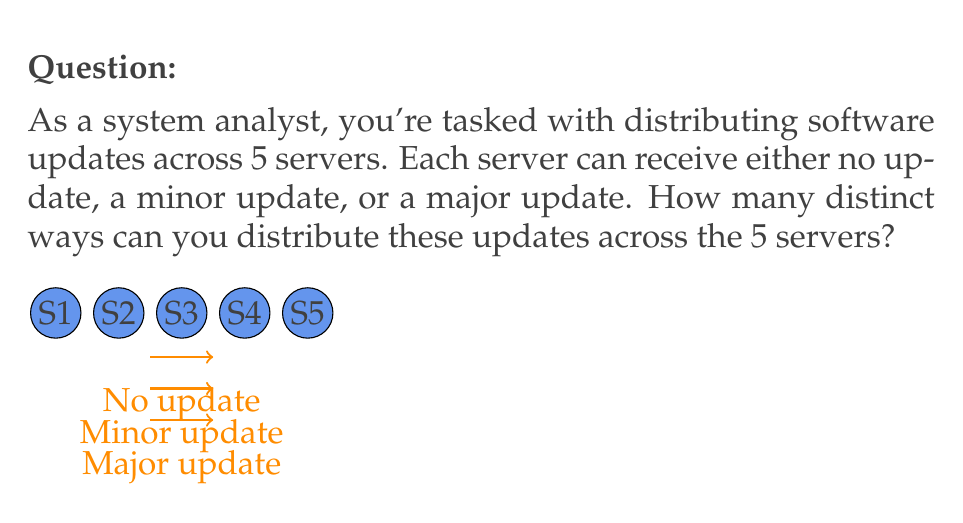Help me with this question. Let's approach this step-by-step:

1) We have 5 servers, and for each server, we have 3 choices:
   - No update
   - Minor update
   - Major update

2) This scenario can be modeled as a combination with repetition problem. We are essentially making 5 independent choices, where each choice has 3 options.

3) In combinatorics, when we have n independent choices, and each choice has k options, the total number of possible outcomes is $k^n$.

4) In this case:
   - n = 5 (number of servers)
   - k = 3 (number of update options for each server)

5) Therefore, the total number of distinct ways to distribute the updates is:

   $$ 3^5 = 3 \times 3 \times 3 \times 3 \times 3 = 243 $$

This means there are 243 different ways to distribute the updates across the 5 servers.
Answer: $3^5 = 243$ 